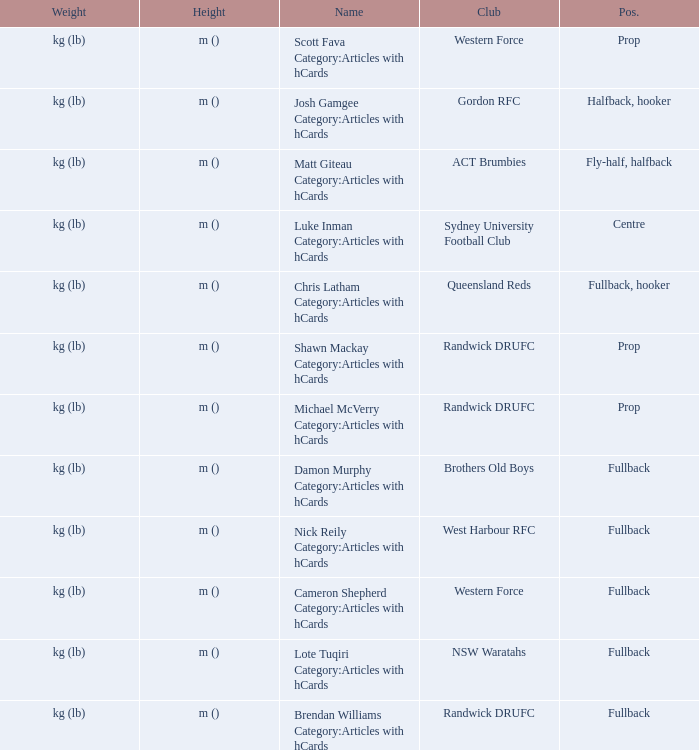What is the name when the position was fullback, hooker? Chris Latham Category:Articles with hCards. 